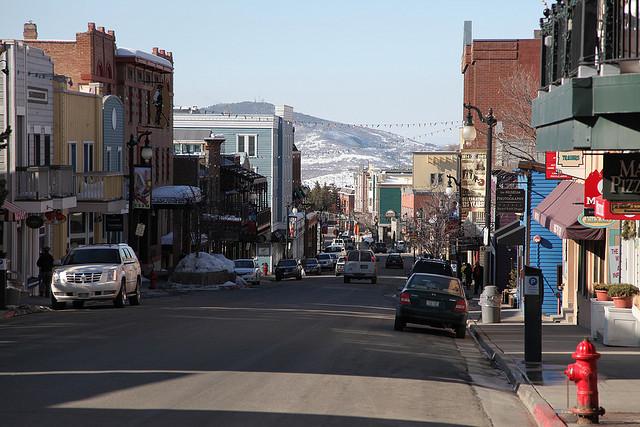Has this picture been filtered?
Keep it brief. No. How many cars are in the picture?
Quick response, please. 10. Are there barricades in the street?
Give a very brief answer. No. Was this photo taken near mountains?
Answer briefly. Yes. How many trash cans are there?
Concise answer only. 1. Is there a fire hydrant in the picture?
Be succinct. Yes. 